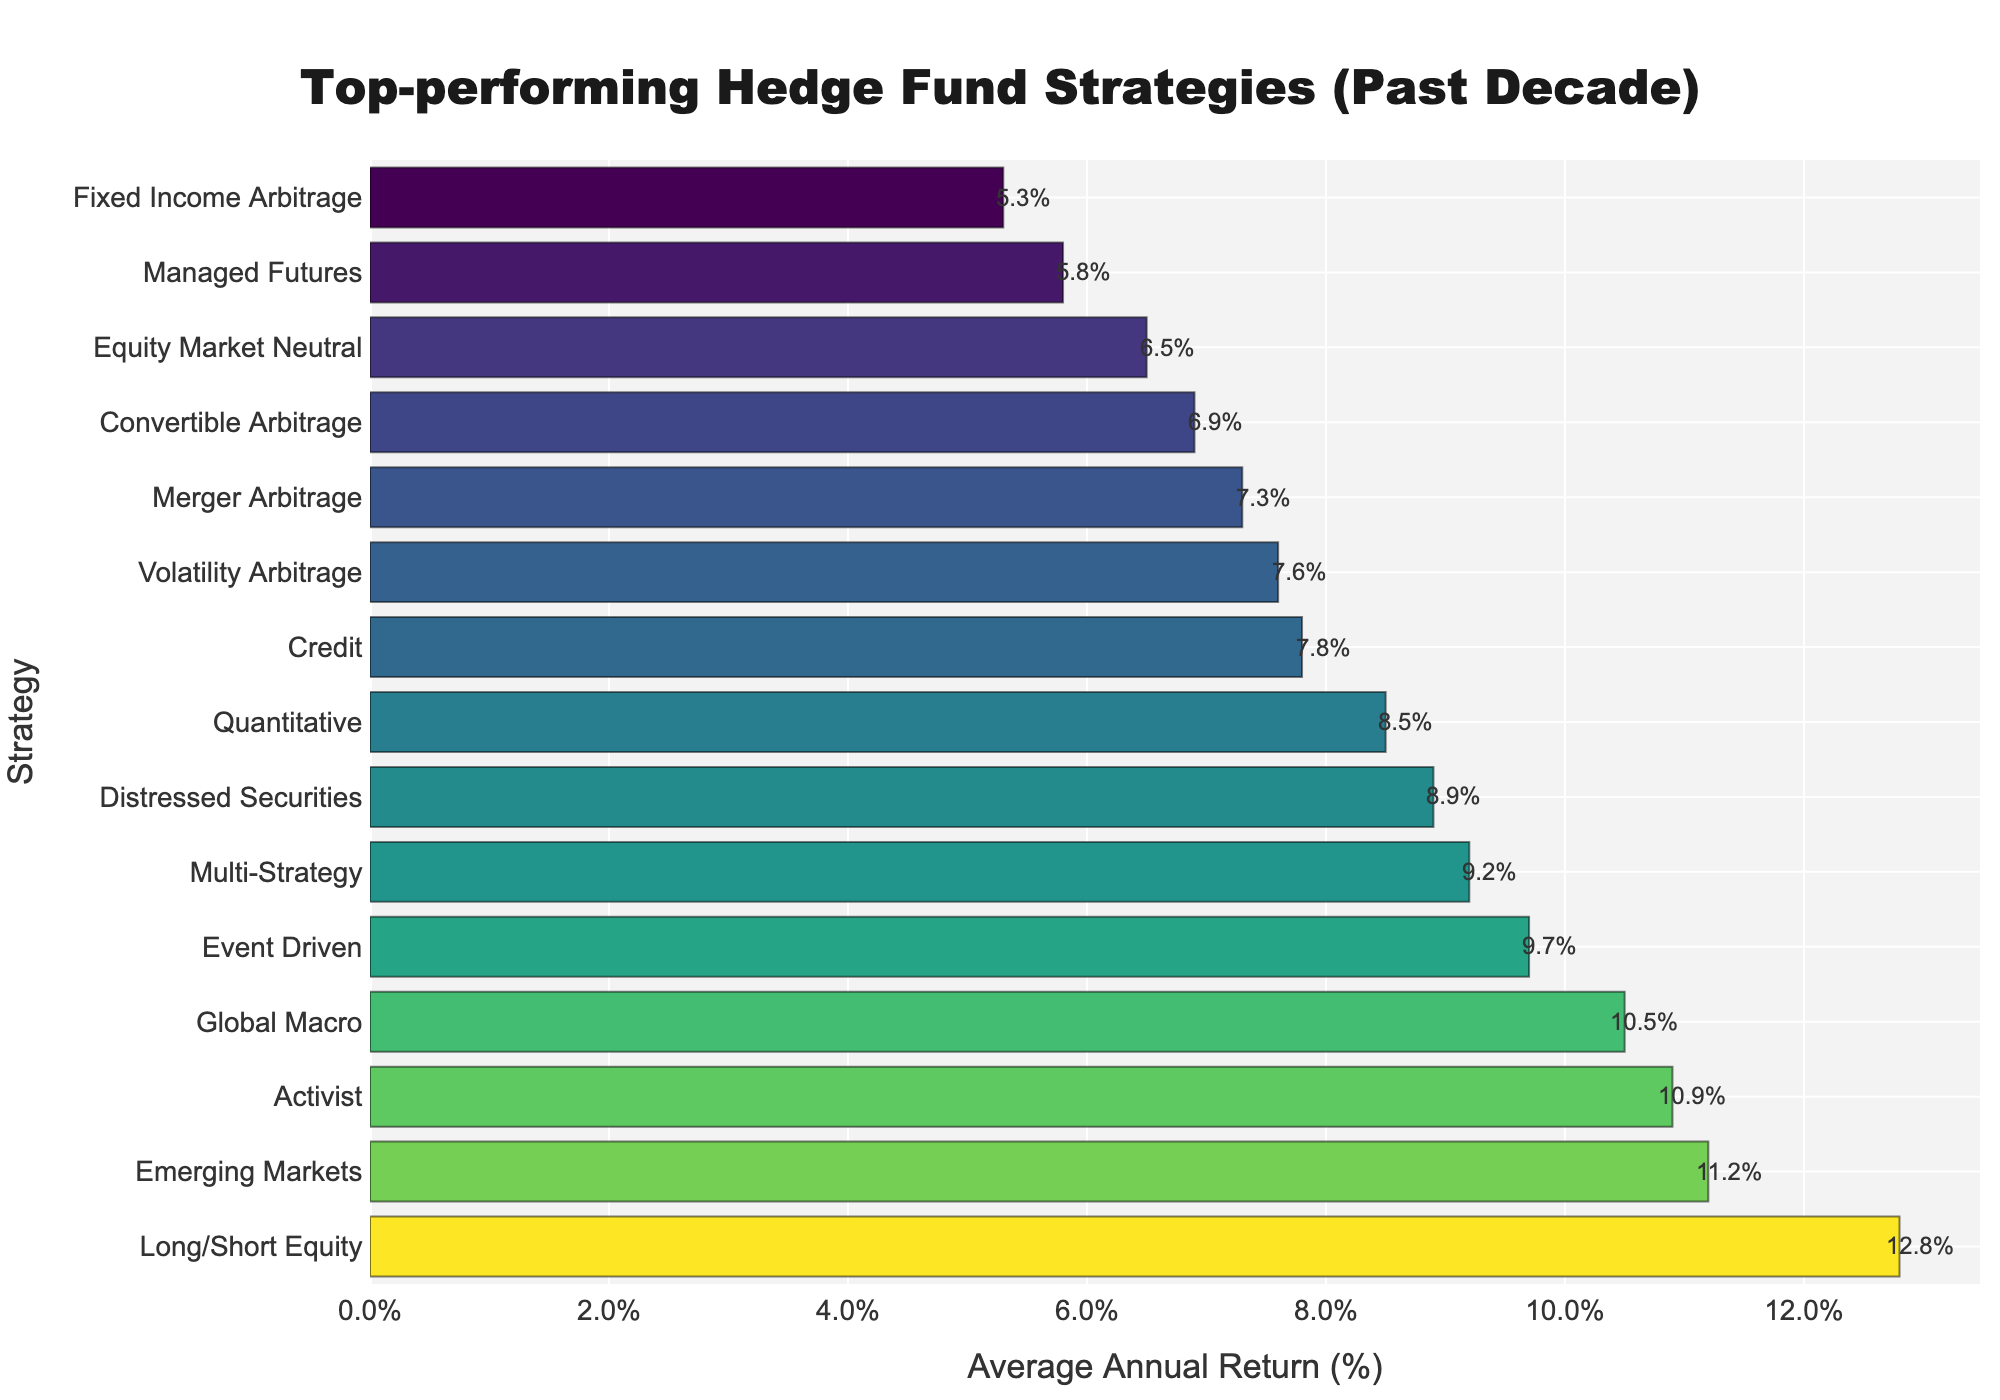What is the top-performing hedge fund strategy? The top-performing hedge fund strategy can be identified as the strategy with the highest average annual return. By observing the chart, we see that 'Long/Short Equity' has the highest value on the x-axis.
Answer: Long/Short Equity Which strategy has the lowest average annual return? To find the strategy with the lowest average annual return, observe the bar with the smallest value on the x-axis. 'Fixed Income Arbitrage' is the strategy with the lowest return.
Answer: Fixed Income Arbitrage How does the average annual return of 'Global Macro' compare to 'Emerging Markets'? Compare the lengths of the bars for 'Global Macro' and 'Emerging Markets'. The chart shows that 'Global Macro' has an average annual return of 10.5%, while 'Emerging Markets' has 11.2%. Thus, 'Emerging Markets' has a higher return.
Answer: Emerging Markets What is the combined average annual return of the top three strategies? The top three strategies can be identified by the longest bars: 'Long/Short Equity', 'Emerging Markets', and 'Activist'. Summing their returns: 12.8% + 11.2% + 10.9% = 34.9%.
Answer: 34.9% How much higher is the return of 'Long/Short Equity' compared to 'Fixed Income Arbitrage'? Calculate the difference between the two returns: 12.8% (Long/Short Equity) - 5.3% (Fixed Income Arbitrage) = 7.5%.
Answer: 7.5% What percentage of strategies have an average annual return above 10%? Count the strategies with returns above 10% and divide by the total number of strategies. Strategies above 10%: 'Long/Short Equity', 'Emerging Markets', 'Activist', 'Global Macro' (4 strategies). Total strategies: 15. Percentage = (4/15) * 100 ≈ 26.67%.
Answer: 26.67% Which strategy has the closest average annual return to the median of all listed returns? First, sort the returns and find the median. The sorted returns: 5.3%, 5.8%, 6.5%, 6.9%, 7.3%, 7.6%, 7.8%, 8.5%, 8.9%, 9.2%, 9.7%, 10.5%, 10.9%, 11.2%, 12.8%. The median value is the 8th value: 8.5% (Quantitative Strategy).
Answer: Quantitative Strategy Between 'Volatility Arbitrage' and 'Credit', which strategy has a higher average annual return and by how much? 'Volatility Arbitrage' has a return of 7.6%, and 'Credit' has 7.8%. 'Credit' has a higher return. Calculate the difference: 7.8% - 7.6% = 0.2%.
Answer: Credit, 0.2% Which strategy has an average annual return closest to the industry average, assuming the industry average return is 8.0%? Identify which bar's value is closest to 8.0%. 'Credit' has a return of 7.8%, which is nearest to 8.0%.
Answer: Credit What is the second least performing strategy in terms of average annual return? Identify the two smallest bars. 'Fixed Income Arbitrage' is the smallest. The next smallest is 'Managed Futures' with a return of 5.8%.
Answer: Managed Futures 